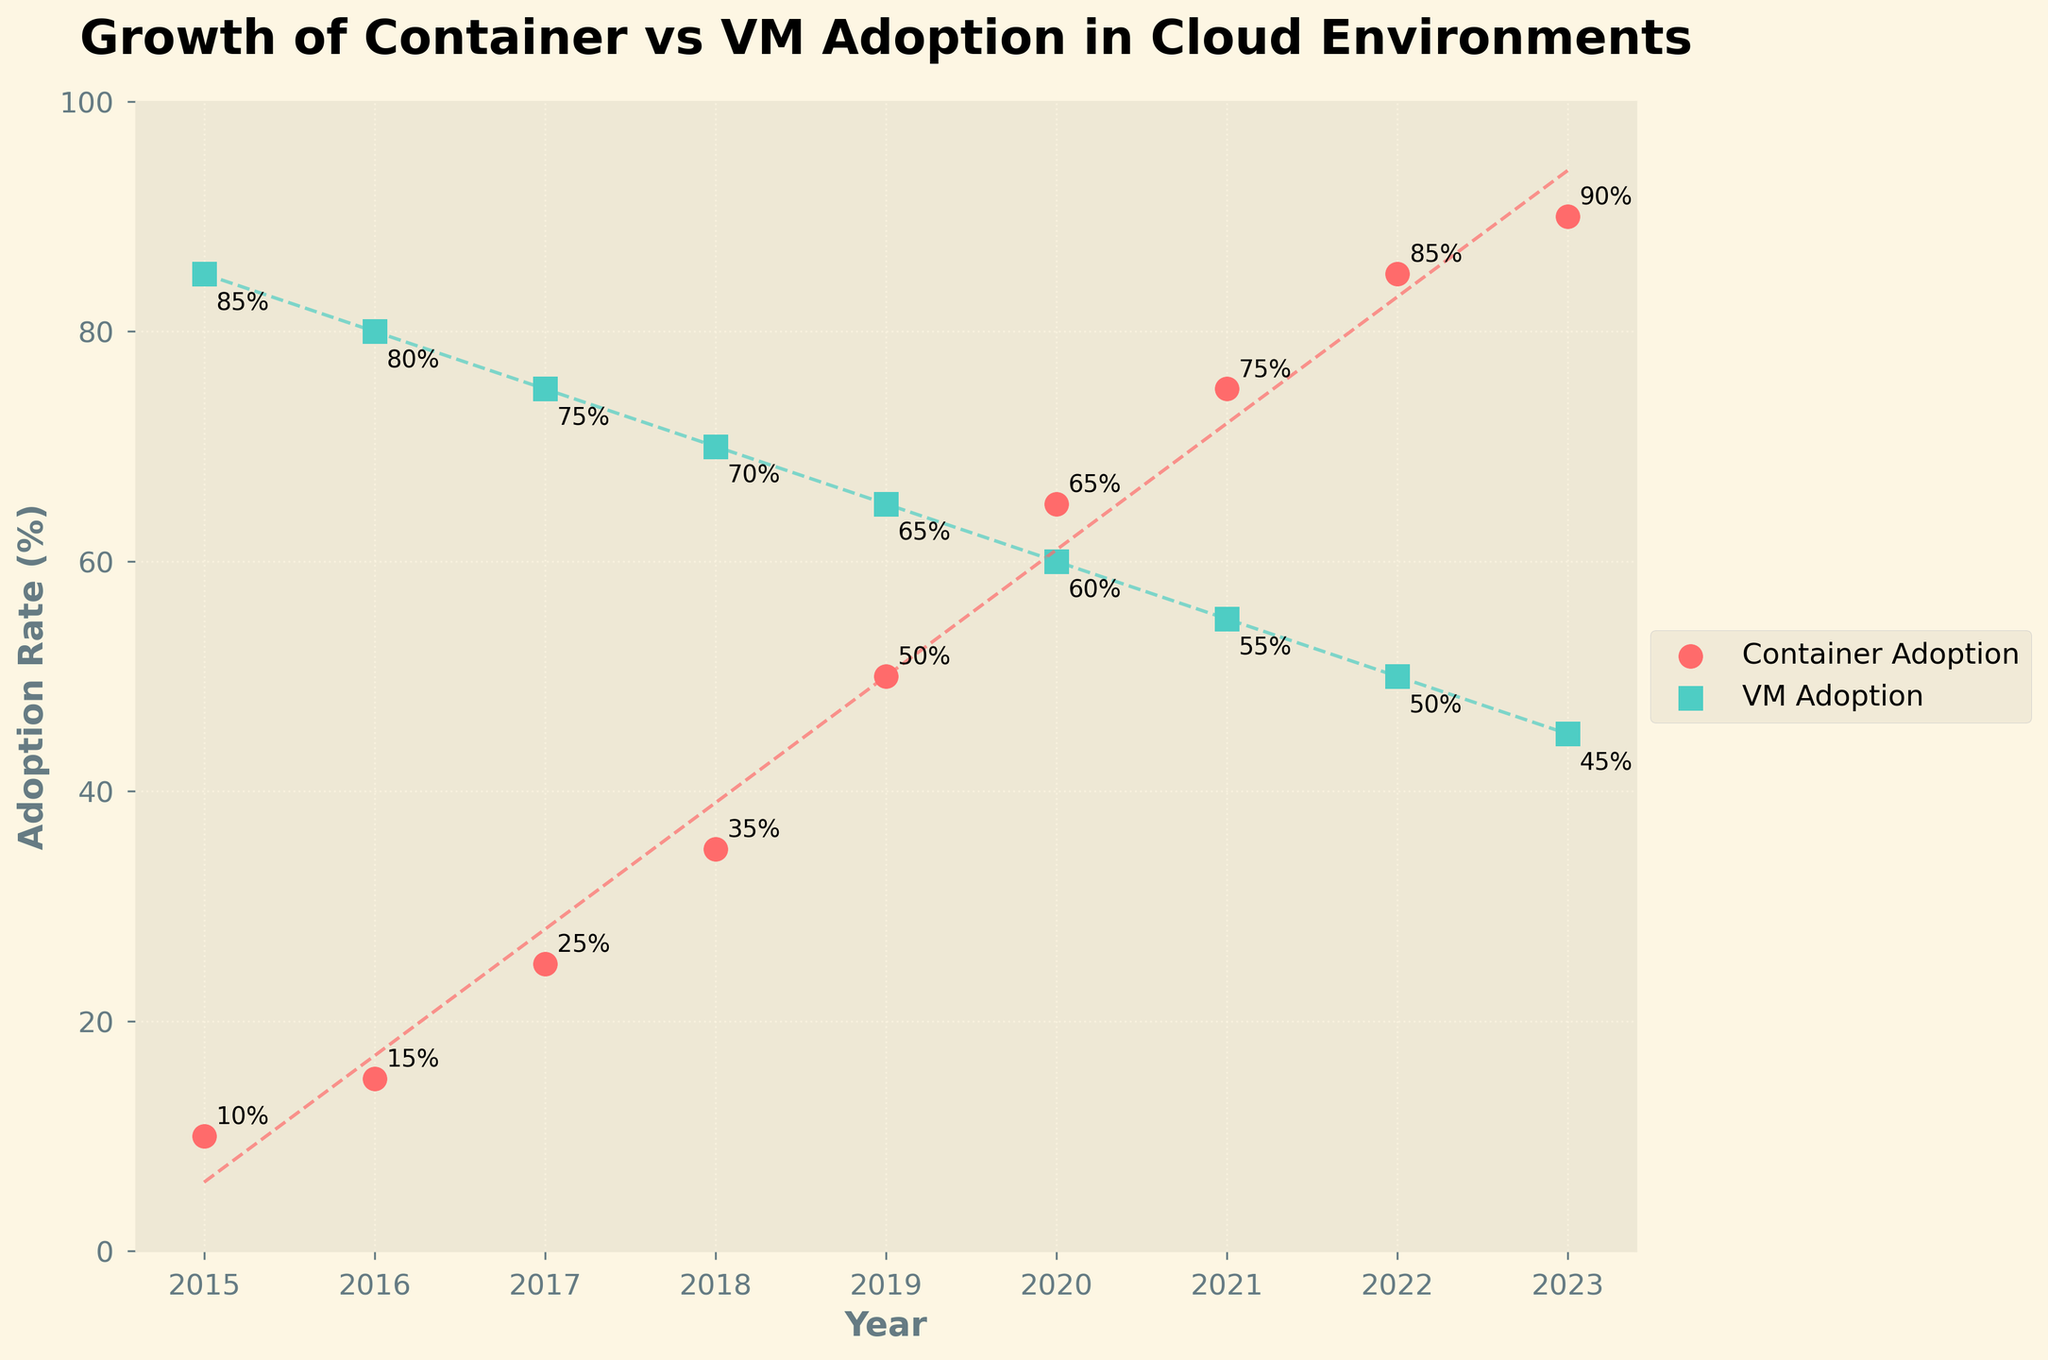What's the title of the figure? The title of the figure is located at the top and provides a summary of the main topic being depicted. In this case, the title concisely communicates the content of the graph.
Answer: Growth of Container vs VM Adoption in Cloud Environments What are the labels on the x and y axes? The labels on the axes are used to describe what each axis represents. In this plot, the x-axis represents the year, and the y-axis represents the adoption rate.
Answer: x-axis: Year, y-axis: Adoption Rate (%) What are the colors used to represent container adoption and VM adoption? The colors differentiate the two types of adoption rates. The figure uses red for container adoption and teal for VM adoption.
Answer: Container adoption is red and VM adoption is teal How many data points are plotted for each adoption type? Count the points on the scatter plot for each adoption type. Each year has one data point for container adoption and one for VM adoption. Since the data ranges from 2015 to 2023, inclusive, there are 9 points each.
Answer: 9 Which adoption type shows a higher rate in 2023? Compare the heights of the data points in 2023 for both adoption types. The container adoption point is higher than the VM adoption point at that year.
Answer: Container adoption Between which two years did the container adoption rate increase the most? Look at the steepest upward movement in the container adoption data points. The biggest increase is from 2018 to 2019, where the adoption rate goes from 35% to 50%.
Answer: 2018 to 2019 Which adoption type has a decreasing trend over the years? Identify which set of points declines over time. The VM adoption shows a decreasing trend as each point is lower than the previous one as years progress.
Answer: VM adoption What's the average adoption rate of containers from 2015 to 2023? Add up the container adoption rates for all the years and divide by the number of years (9). (10 + 15 + 25 + 35 + 50 + 65 + 75 + 85 + 90) / 9 = 50%
Answer: 50% Did VM adoption ever go below 50% during the period 2015 to 2023? Check the y-axis values of the VM adoption points to see if any point dips below 50%. The VM adoption rate decreases to 45% by 2023, which is below 50%.
Answer: Yes Comparing container and VM adoption rates in 2016, which one was higher and by how much? Find the corresponding adoption rates for 2016, and subtract the container adoption from the VM adoption rate. VM adoption in 2016 was 80% and container adoption was 15%, so the difference is 80% - 15% = 65%.
Answer: VM adoption by 65% 